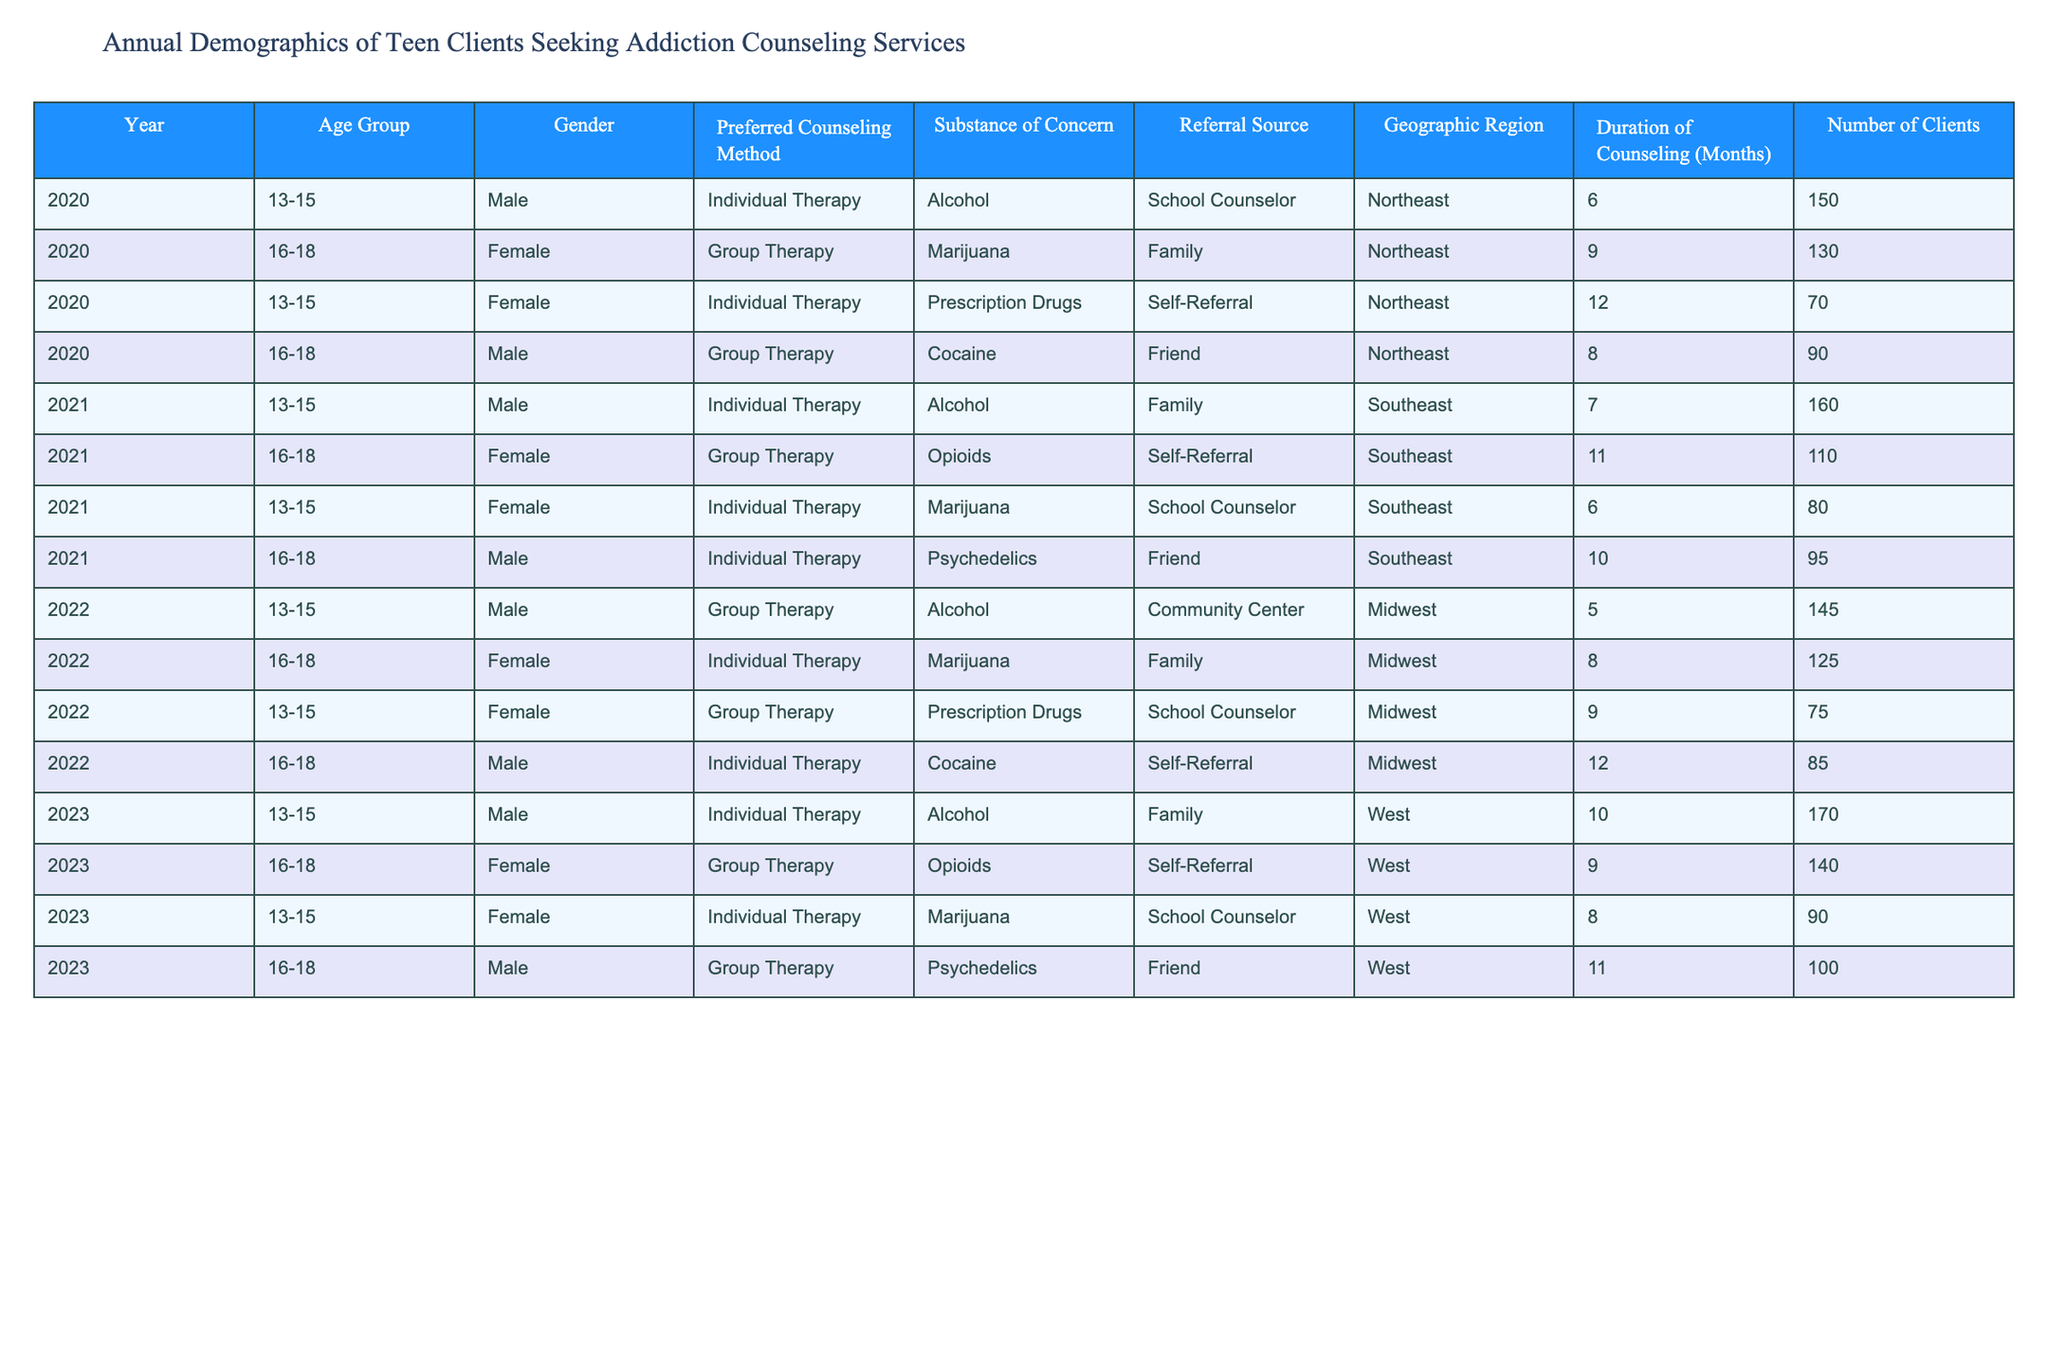What is the total number of clients for the year 2022? To find the total number of clients for 2022, I need to sum the 'Number of Clients' for that year. The clients in 2022 are: 145 (male, 13-15), 125 (female, 16-18), 75 (female, 13-15), and 85 (male, 16-18). Adding these gives: 145 + 125 + 75 + 85 = 430.
Answer: 430 Which gender had more clients in the age group 16-18 in 2021? I will check the 'Number of Clients' for each gender in the 16-18 age group for 2021. The data shows 110 female clients and 95 male clients. Since 110 > 95, female clients are greater.
Answer: Female What was the preferred counseling method for the most clients in 2023? To find out the preferred counseling method for the most clients in 2023, I will look at the 'Preferred Counseling Method' along with the 'Number of Clients' for that year. The methods are: Individual Therapy (170), Group Therapy (140), Individual Therapy (90), and Group Therapy (100). The highest number of clients (170) is from Individual Therapy.
Answer: Individual Therapy How many clients were referred by a school counselor in 2020? I will check the 'Referral Source' for clients in 2020 who were referred by a school counselor. The clients in 2020 are: 150 (male, Individual Therapy, Alcohol), 130 (female, Group Therapy, Marijuana), 70 (female, Individual Therapy, Prescription Drugs), and 90 (male, Group Therapy, Cocaine). The referral from a school counselor is 150 and 70, summing those gives: 70.
Answer: 70 What is the average duration of counseling for clients under 16 years old across all the years? First, I need to find all clients aged 13-15 across all years and their 'Duration of Counseling'. The durations are: 6 months (150), 12 months (70), 7 months (160), 6 months (80), 5 months (145), 10 months (170), and 8 months (90). Counting gives 7 data points and their sum is: 6 + 12 + 7 + 6 + 5 + 10 + 8 = 54. Then, dividing the total by the number of clients (54/7) gives approximately 7.71 months.
Answer: Approximately 7.71 months Is there a year where the number of female clients exceeded the number of male clients across all age groups? I will check each year for the total number of clients by gender. The totals are: 2020 (130 female, 240 male), 2021 (110 female, 255 male), 2022 (125 female, 220 male), and 2023 (140 female, 270 male). All years show that males had a higher total than females, therefore, no year has more female clients than male clients.
Answer: No What trend can be observed in the number of clients aged 13-15 from 2020 to 2023? I will list the number of clients aged 13-15 for each year: 2020 has 150 (male), 2021 has 160 (male), 2022 has 145 (male), and 2023 has 170 (male). The trend shows an increase from 150 to 160, a decrease to 145, and then an increase to 170, indicating fluctuations with a net positive increase over these years.
Answer: Fluctuating increase How many clients reported opioids as the substance of concern, and what was their method of counseling? I check the entries under 'Substance of Concern' for opioids and observe the corresponding 'Preferred Counseling Method'. There are two instances of opioids: 110 clients (female, Group Therapy) in 2021 and 140 clients (female, Group Therapy) in 2023. Both used Group Therapy.
Answer: 250 clients, Group Therapy 